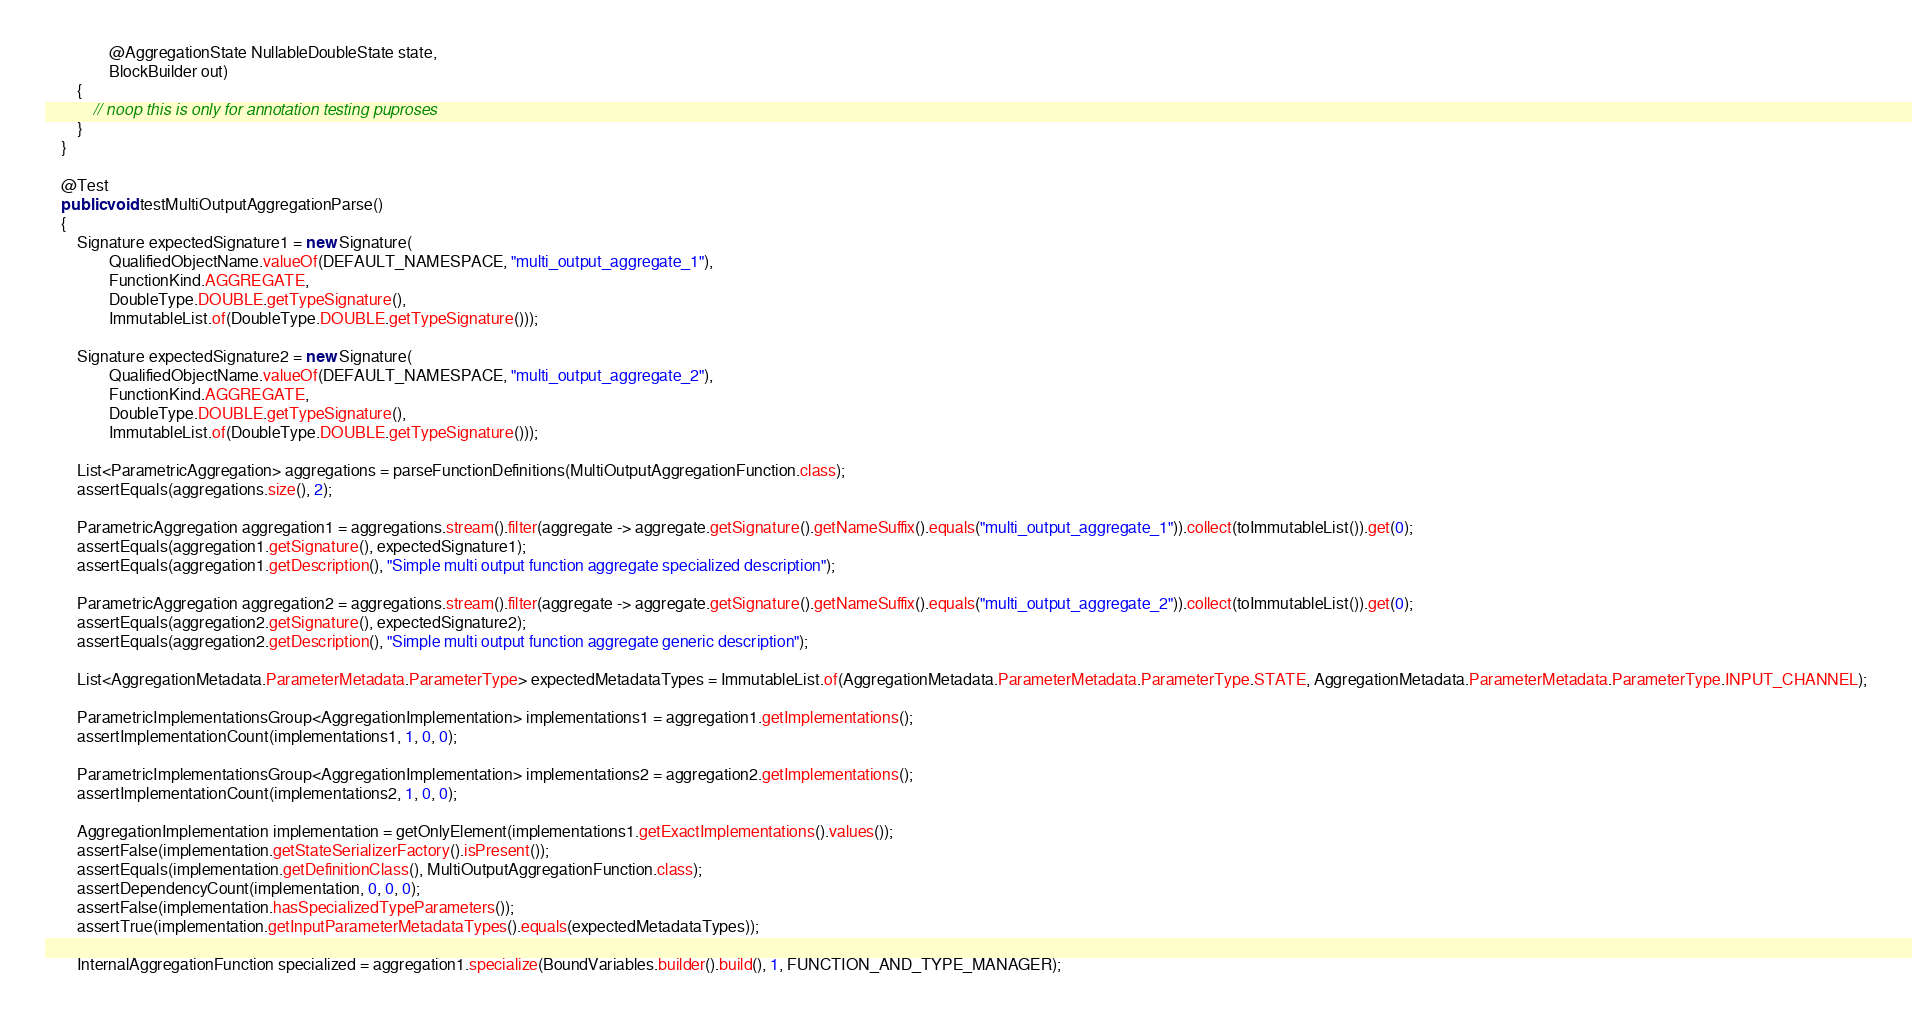<code> <loc_0><loc_0><loc_500><loc_500><_Java_>                @AggregationState NullableDoubleState state,
                BlockBuilder out)
        {
            // noop this is only for annotation testing puproses
        }
    }

    @Test
    public void testMultiOutputAggregationParse()
    {
        Signature expectedSignature1 = new Signature(
                QualifiedObjectName.valueOf(DEFAULT_NAMESPACE, "multi_output_aggregate_1"),
                FunctionKind.AGGREGATE,
                DoubleType.DOUBLE.getTypeSignature(),
                ImmutableList.of(DoubleType.DOUBLE.getTypeSignature()));

        Signature expectedSignature2 = new Signature(
                QualifiedObjectName.valueOf(DEFAULT_NAMESPACE, "multi_output_aggregate_2"),
                FunctionKind.AGGREGATE,
                DoubleType.DOUBLE.getTypeSignature(),
                ImmutableList.of(DoubleType.DOUBLE.getTypeSignature()));

        List<ParametricAggregation> aggregations = parseFunctionDefinitions(MultiOutputAggregationFunction.class);
        assertEquals(aggregations.size(), 2);

        ParametricAggregation aggregation1 = aggregations.stream().filter(aggregate -> aggregate.getSignature().getNameSuffix().equals("multi_output_aggregate_1")).collect(toImmutableList()).get(0);
        assertEquals(aggregation1.getSignature(), expectedSignature1);
        assertEquals(aggregation1.getDescription(), "Simple multi output function aggregate specialized description");

        ParametricAggregation aggregation2 = aggregations.stream().filter(aggregate -> aggregate.getSignature().getNameSuffix().equals("multi_output_aggregate_2")).collect(toImmutableList()).get(0);
        assertEquals(aggregation2.getSignature(), expectedSignature2);
        assertEquals(aggregation2.getDescription(), "Simple multi output function aggregate generic description");

        List<AggregationMetadata.ParameterMetadata.ParameterType> expectedMetadataTypes = ImmutableList.of(AggregationMetadata.ParameterMetadata.ParameterType.STATE, AggregationMetadata.ParameterMetadata.ParameterType.INPUT_CHANNEL);

        ParametricImplementationsGroup<AggregationImplementation> implementations1 = aggregation1.getImplementations();
        assertImplementationCount(implementations1, 1, 0, 0);

        ParametricImplementationsGroup<AggregationImplementation> implementations2 = aggregation2.getImplementations();
        assertImplementationCount(implementations2, 1, 0, 0);

        AggregationImplementation implementation = getOnlyElement(implementations1.getExactImplementations().values());
        assertFalse(implementation.getStateSerializerFactory().isPresent());
        assertEquals(implementation.getDefinitionClass(), MultiOutputAggregationFunction.class);
        assertDependencyCount(implementation, 0, 0, 0);
        assertFalse(implementation.hasSpecializedTypeParameters());
        assertTrue(implementation.getInputParameterMetadataTypes().equals(expectedMetadataTypes));

        InternalAggregationFunction specialized = aggregation1.specialize(BoundVariables.builder().build(), 1, FUNCTION_AND_TYPE_MANAGER);</code> 